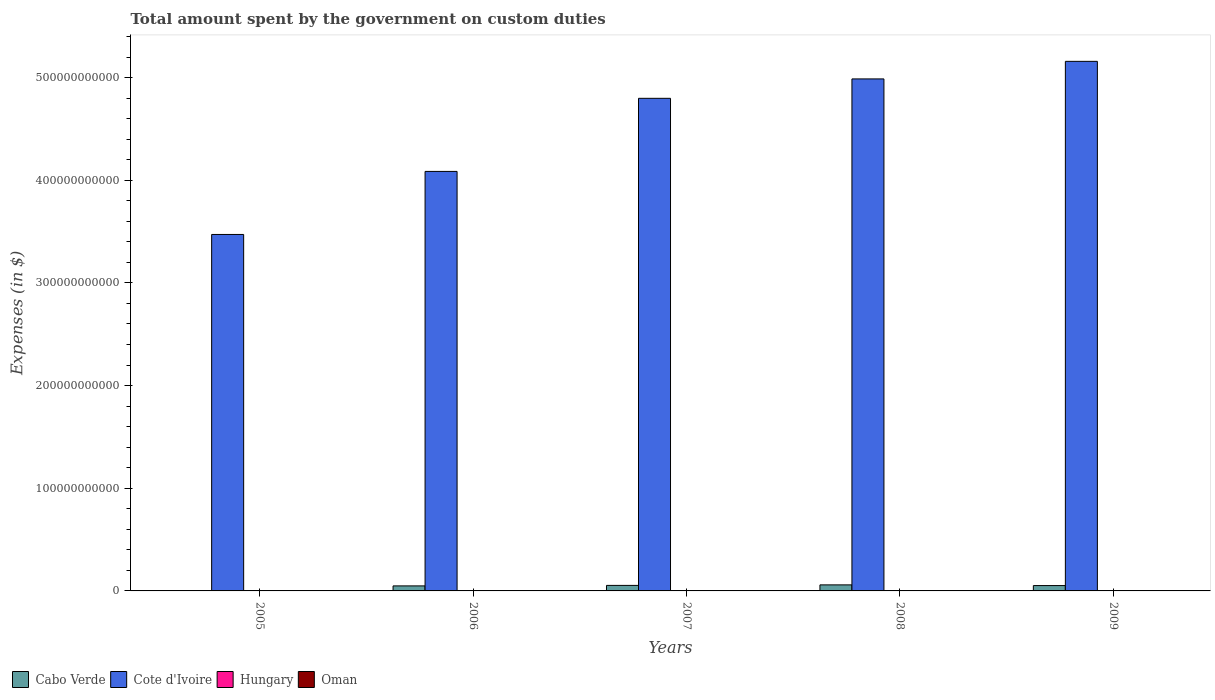Are the number of bars per tick equal to the number of legend labels?
Your answer should be very brief. No. Are the number of bars on each tick of the X-axis equal?
Ensure brevity in your answer.  Yes. What is the label of the 2nd group of bars from the left?
Offer a terse response. 2006. What is the amount spent on custom duties by the government in Oman in 2009?
Offer a very short reply. 1.58e+08. Across all years, what is the maximum amount spent on custom duties by the government in Cote d'Ivoire?
Offer a very short reply. 5.16e+11. Across all years, what is the minimum amount spent on custom duties by the government in Cabo Verde?
Your answer should be very brief. 2.89e+07. What is the total amount spent on custom duties by the government in Cote d'Ivoire in the graph?
Ensure brevity in your answer.  2.25e+12. What is the difference between the amount spent on custom duties by the government in Cabo Verde in 2006 and that in 2007?
Give a very brief answer. -4.88e+08. What is the difference between the amount spent on custom duties by the government in Hungary in 2008 and the amount spent on custom duties by the government in Cabo Verde in 2009?
Ensure brevity in your answer.  -5.22e+09. What is the average amount spent on custom duties by the government in Hungary per year?
Make the answer very short. 0. In the year 2005, what is the difference between the amount spent on custom duties by the government in Oman and amount spent on custom duties by the government in Cote d'Ivoire?
Provide a short and direct response. -3.47e+11. In how many years, is the amount spent on custom duties by the government in Cote d'Ivoire greater than 360000000000 $?
Ensure brevity in your answer.  4. What is the ratio of the amount spent on custom duties by the government in Cote d'Ivoire in 2005 to that in 2007?
Offer a terse response. 0.72. Is the difference between the amount spent on custom duties by the government in Oman in 2006 and 2009 greater than the difference between the amount spent on custom duties by the government in Cote d'Ivoire in 2006 and 2009?
Offer a very short reply. Yes. What is the difference between the highest and the second highest amount spent on custom duties by the government in Oman?
Ensure brevity in your answer.  6.70e+07. What is the difference between the highest and the lowest amount spent on custom duties by the government in Cote d'Ivoire?
Provide a succinct answer. 1.69e+11. In how many years, is the amount spent on custom duties by the government in Cabo Verde greater than the average amount spent on custom duties by the government in Cabo Verde taken over all years?
Keep it short and to the point. 4. Is the sum of the amount spent on custom duties by the government in Cote d'Ivoire in 2005 and 2008 greater than the maximum amount spent on custom duties by the government in Hungary across all years?
Provide a succinct answer. Yes. How many bars are there?
Offer a terse response. 15. How many years are there in the graph?
Your answer should be compact. 5. What is the difference between two consecutive major ticks on the Y-axis?
Give a very brief answer. 1.00e+11. Are the values on the major ticks of Y-axis written in scientific E-notation?
Your response must be concise. No. Does the graph contain grids?
Ensure brevity in your answer.  No. Where does the legend appear in the graph?
Keep it short and to the point. Bottom left. What is the title of the graph?
Make the answer very short. Total amount spent by the government on custom duties. What is the label or title of the X-axis?
Your answer should be compact. Years. What is the label or title of the Y-axis?
Provide a succinct answer. Expenses (in $). What is the Expenses (in $) of Cabo Verde in 2005?
Make the answer very short. 2.89e+07. What is the Expenses (in $) in Cote d'Ivoire in 2005?
Provide a short and direct response. 3.47e+11. What is the Expenses (in $) of Hungary in 2005?
Offer a terse response. 0. What is the Expenses (in $) in Oman in 2005?
Provide a short and direct response. 8.85e+07. What is the Expenses (in $) in Cabo Verde in 2006?
Provide a succinct answer. 4.89e+09. What is the Expenses (in $) of Cote d'Ivoire in 2006?
Your response must be concise. 4.09e+11. What is the Expenses (in $) in Oman in 2006?
Offer a very short reply. 1.15e+08. What is the Expenses (in $) of Cabo Verde in 2007?
Offer a terse response. 5.38e+09. What is the Expenses (in $) in Cote d'Ivoire in 2007?
Ensure brevity in your answer.  4.80e+11. What is the Expenses (in $) of Oman in 2007?
Provide a succinct answer. 1.60e+08. What is the Expenses (in $) of Cabo Verde in 2008?
Your answer should be compact. 5.89e+09. What is the Expenses (in $) of Cote d'Ivoire in 2008?
Your response must be concise. 4.99e+11. What is the Expenses (in $) of Hungary in 2008?
Your answer should be very brief. 0. What is the Expenses (in $) of Oman in 2008?
Your response must be concise. 2.27e+08. What is the Expenses (in $) in Cabo Verde in 2009?
Make the answer very short. 5.22e+09. What is the Expenses (in $) of Cote d'Ivoire in 2009?
Your answer should be very brief. 5.16e+11. What is the Expenses (in $) in Hungary in 2009?
Give a very brief answer. 0. What is the Expenses (in $) in Oman in 2009?
Ensure brevity in your answer.  1.58e+08. Across all years, what is the maximum Expenses (in $) in Cabo Verde?
Provide a short and direct response. 5.89e+09. Across all years, what is the maximum Expenses (in $) in Cote d'Ivoire?
Your response must be concise. 5.16e+11. Across all years, what is the maximum Expenses (in $) of Oman?
Keep it short and to the point. 2.27e+08. Across all years, what is the minimum Expenses (in $) of Cabo Verde?
Provide a succinct answer. 2.89e+07. Across all years, what is the minimum Expenses (in $) in Cote d'Ivoire?
Offer a very short reply. 3.47e+11. Across all years, what is the minimum Expenses (in $) of Oman?
Your answer should be very brief. 8.85e+07. What is the total Expenses (in $) in Cabo Verde in the graph?
Your answer should be very brief. 2.14e+1. What is the total Expenses (in $) of Cote d'Ivoire in the graph?
Make the answer very short. 2.25e+12. What is the total Expenses (in $) of Oman in the graph?
Your answer should be compact. 7.47e+08. What is the difference between the Expenses (in $) of Cabo Verde in 2005 and that in 2006?
Provide a short and direct response. -4.86e+09. What is the difference between the Expenses (in $) in Cote d'Ivoire in 2005 and that in 2006?
Give a very brief answer. -6.14e+1. What is the difference between the Expenses (in $) in Oman in 2005 and that in 2006?
Make the answer very short. -2.61e+07. What is the difference between the Expenses (in $) in Cabo Verde in 2005 and that in 2007?
Provide a succinct answer. -5.35e+09. What is the difference between the Expenses (in $) in Cote d'Ivoire in 2005 and that in 2007?
Provide a short and direct response. -1.33e+11. What is the difference between the Expenses (in $) in Oman in 2005 and that in 2007?
Provide a succinct answer. -7.11e+07. What is the difference between the Expenses (in $) of Cabo Verde in 2005 and that in 2008?
Offer a very short reply. -5.86e+09. What is the difference between the Expenses (in $) of Cote d'Ivoire in 2005 and that in 2008?
Make the answer very short. -1.52e+11. What is the difference between the Expenses (in $) of Oman in 2005 and that in 2008?
Keep it short and to the point. -1.38e+08. What is the difference between the Expenses (in $) in Cabo Verde in 2005 and that in 2009?
Ensure brevity in your answer.  -5.19e+09. What is the difference between the Expenses (in $) in Cote d'Ivoire in 2005 and that in 2009?
Make the answer very short. -1.69e+11. What is the difference between the Expenses (in $) of Oman in 2005 and that in 2009?
Provide a succinct answer. -6.96e+07. What is the difference between the Expenses (in $) in Cabo Verde in 2006 and that in 2007?
Ensure brevity in your answer.  -4.88e+08. What is the difference between the Expenses (in $) of Cote d'Ivoire in 2006 and that in 2007?
Your answer should be compact. -7.12e+1. What is the difference between the Expenses (in $) of Oman in 2006 and that in 2007?
Make the answer very short. -4.50e+07. What is the difference between the Expenses (in $) in Cabo Verde in 2006 and that in 2008?
Your response must be concise. -9.99e+08. What is the difference between the Expenses (in $) in Cote d'Ivoire in 2006 and that in 2008?
Your response must be concise. -9.01e+1. What is the difference between the Expenses (in $) of Oman in 2006 and that in 2008?
Ensure brevity in your answer.  -1.12e+08. What is the difference between the Expenses (in $) of Cabo Verde in 2006 and that in 2009?
Offer a very short reply. -3.30e+08. What is the difference between the Expenses (in $) of Cote d'Ivoire in 2006 and that in 2009?
Provide a short and direct response. -1.07e+11. What is the difference between the Expenses (in $) of Oman in 2006 and that in 2009?
Ensure brevity in your answer.  -4.35e+07. What is the difference between the Expenses (in $) of Cabo Verde in 2007 and that in 2008?
Make the answer very short. -5.12e+08. What is the difference between the Expenses (in $) of Cote d'Ivoire in 2007 and that in 2008?
Offer a very short reply. -1.89e+1. What is the difference between the Expenses (in $) of Oman in 2007 and that in 2008?
Provide a succinct answer. -6.70e+07. What is the difference between the Expenses (in $) in Cabo Verde in 2007 and that in 2009?
Make the answer very short. 1.57e+08. What is the difference between the Expenses (in $) of Cote d'Ivoire in 2007 and that in 2009?
Offer a terse response. -3.60e+1. What is the difference between the Expenses (in $) in Oman in 2007 and that in 2009?
Your response must be concise. 1.50e+06. What is the difference between the Expenses (in $) of Cabo Verde in 2008 and that in 2009?
Make the answer very short. 6.69e+08. What is the difference between the Expenses (in $) in Cote d'Ivoire in 2008 and that in 2009?
Make the answer very short. -1.71e+1. What is the difference between the Expenses (in $) of Oman in 2008 and that in 2009?
Ensure brevity in your answer.  6.85e+07. What is the difference between the Expenses (in $) in Cabo Verde in 2005 and the Expenses (in $) in Cote d'Ivoire in 2006?
Your response must be concise. -4.09e+11. What is the difference between the Expenses (in $) in Cabo Verde in 2005 and the Expenses (in $) in Oman in 2006?
Offer a terse response. -8.57e+07. What is the difference between the Expenses (in $) in Cote d'Ivoire in 2005 and the Expenses (in $) in Oman in 2006?
Offer a terse response. 3.47e+11. What is the difference between the Expenses (in $) of Cabo Verde in 2005 and the Expenses (in $) of Cote d'Ivoire in 2007?
Your answer should be compact. -4.80e+11. What is the difference between the Expenses (in $) in Cabo Verde in 2005 and the Expenses (in $) in Oman in 2007?
Ensure brevity in your answer.  -1.31e+08. What is the difference between the Expenses (in $) in Cote d'Ivoire in 2005 and the Expenses (in $) in Oman in 2007?
Offer a very short reply. 3.47e+11. What is the difference between the Expenses (in $) in Cabo Verde in 2005 and the Expenses (in $) in Cote d'Ivoire in 2008?
Offer a terse response. -4.99e+11. What is the difference between the Expenses (in $) in Cabo Verde in 2005 and the Expenses (in $) in Oman in 2008?
Your answer should be compact. -1.98e+08. What is the difference between the Expenses (in $) of Cote d'Ivoire in 2005 and the Expenses (in $) of Oman in 2008?
Provide a succinct answer. 3.47e+11. What is the difference between the Expenses (in $) of Cabo Verde in 2005 and the Expenses (in $) of Cote d'Ivoire in 2009?
Give a very brief answer. -5.16e+11. What is the difference between the Expenses (in $) of Cabo Verde in 2005 and the Expenses (in $) of Oman in 2009?
Offer a terse response. -1.29e+08. What is the difference between the Expenses (in $) of Cote d'Ivoire in 2005 and the Expenses (in $) of Oman in 2009?
Offer a terse response. 3.47e+11. What is the difference between the Expenses (in $) in Cabo Verde in 2006 and the Expenses (in $) in Cote d'Ivoire in 2007?
Provide a succinct answer. -4.75e+11. What is the difference between the Expenses (in $) of Cabo Verde in 2006 and the Expenses (in $) of Oman in 2007?
Your answer should be compact. 4.73e+09. What is the difference between the Expenses (in $) of Cote d'Ivoire in 2006 and the Expenses (in $) of Oman in 2007?
Provide a succinct answer. 4.08e+11. What is the difference between the Expenses (in $) in Cabo Verde in 2006 and the Expenses (in $) in Cote d'Ivoire in 2008?
Your answer should be very brief. -4.94e+11. What is the difference between the Expenses (in $) in Cabo Verde in 2006 and the Expenses (in $) in Oman in 2008?
Ensure brevity in your answer.  4.66e+09. What is the difference between the Expenses (in $) of Cote d'Ivoire in 2006 and the Expenses (in $) of Oman in 2008?
Make the answer very short. 4.08e+11. What is the difference between the Expenses (in $) of Cabo Verde in 2006 and the Expenses (in $) of Cote d'Ivoire in 2009?
Provide a short and direct response. -5.11e+11. What is the difference between the Expenses (in $) of Cabo Verde in 2006 and the Expenses (in $) of Oman in 2009?
Ensure brevity in your answer.  4.73e+09. What is the difference between the Expenses (in $) of Cote d'Ivoire in 2006 and the Expenses (in $) of Oman in 2009?
Give a very brief answer. 4.08e+11. What is the difference between the Expenses (in $) in Cabo Verde in 2007 and the Expenses (in $) in Cote d'Ivoire in 2008?
Offer a terse response. -4.93e+11. What is the difference between the Expenses (in $) of Cabo Verde in 2007 and the Expenses (in $) of Oman in 2008?
Give a very brief answer. 5.15e+09. What is the difference between the Expenses (in $) of Cote d'Ivoire in 2007 and the Expenses (in $) of Oman in 2008?
Ensure brevity in your answer.  4.80e+11. What is the difference between the Expenses (in $) in Cabo Verde in 2007 and the Expenses (in $) in Cote d'Ivoire in 2009?
Give a very brief answer. -5.10e+11. What is the difference between the Expenses (in $) of Cabo Verde in 2007 and the Expenses (in $) of Oman in 2009?
Make the answer very short. 5.22e+09. What is the difference between the Expenses (in $) of Cote d'Ivoire in 2007 and the Expenses (in $) of Oman in 2009?
Provide a succinct answer. 4.80e+11. What is the difference between the Expenses (in $) in Cabo Verde in 2008 and the Expenses (in $) in Cote d'Ivoire in 2009?
Provide a succinct answer. -5.10e+11. What is the difference between the Expenses (in $) of Cabo Verde in 2008 and the Expenses (in $) of Oman in 2009?
Give a very brief answer. 5.73e+09. What is the difference between the Expenses (in $) of Cote d'Ivoire in 2008 and the Expenses (in $) of Oman in 2009?
Make the answer very short. 4.99e+11. What is the average Expenses (in $) of Cabo Verde per year?
Give a very brief answer. 4.28e+09. What is the average Expenses (in $) of Cote d'Ivoire per year?
Offer a terse response. 4.50e+11. What is the average Expenses (in $) of Oman per year?
Give a very brief answer. 1.49e+08. In the year 2005, what is the difference between the Expenses (in $) in Cabo Verde and Expenses (in $) in Cote d'Ivoire?
Give a very brief answer. -3.47e+11. In the year 2005, what is the difference between the Expenses (in $) in Cabo Verde and Expenses (in $) in Oman?
Your answer should be very brief. -5.96e+07. In the year 2005, what is the difference between the Expenses (in $) of Cote d'Ivoire and Expenses (in $) of Oman?
Your answer should be compact. 3.47e+11. In the year 2006, what is the difference between the Expenses (in $) of Cabo Verde and Expenses (in $) of Cote d'Ivoire?
Keep it short and to the point. -4.04e+11. In the year 2006, what is the difference between the Expenses (in $) of Cabo Verde and Expenses (in $) of Oman?
Provide a succinct answer. 4.77e+09. In the year 2006, what is the difference between the Expenses (in $) of Cote d'Ivoire and Expenses (in $) of Oman?
Your response must be concise. 4.08e+11. In the year 2007, what is the difference between the Expenses (in $) of Cabo Verde and Expenses (in $) of Cote d'Ivoire?
Provide a succinct answer. -4.74e+11. In the year 2007, what is the difference between the Expenses (in $) in Cabo Verde and Expenses (in $) in Oman?
Provide a succinct answer. 5.22e+09. In the year 2007, what is the difference between the Expenses (in $) in Cote d'Ivoire and Expenses (in $) in Oman?
Provide a succinct answer. 4.80e+11. In the year 2008, what is the difference between the Expenses (in $) in Cabo Verde and Expenses (in $) in Cote d'Ivoire?
Keep it short and to the point. -4.93e+11. In the year 2008, what is the difference between the Expenses (in $) in Cabo Verde and Expenses (in $) in Oman?
Offer a very short reply. 5.66e+09. In the year 2008, what is the difference between the Expenses (in $) in Cote d'Ivoire and Expenses (in $) in Oman?
Keep it short and to the point. 4.98e+11. In the year 2009, what is the difference between the Expenses (in $) in Cabo Verde and Expenses (in $) in Cote d'Ivoire?
Provide a succinct answer. -5.11e+11. In the year 2009, what is the difference between the Expenses (in $) of Cabo Verde and Expenses (in $) of Oman?
Provide a succinct answer. 5.06e+09. In the year 2009, what is the difference between the Expenses (in $) of Cote d'Ivoire and Expenses (in $) of Oman?
Your answer should be compact. 5.16e+11. What is the ratio of the Expenses (in $) in Cabo Verde in 2005 to that in 2006?
Keep it short and to the point. 0.01. What is the ratio of the Expenses (in $) of Cote d'Ivoire in 2005 to that in 2006?
Offer a terse response. 0.85. What is the ratio of the Expenses (in $) in Oman in 2005 to that in 2006?
Your answer should be very brief. 0.77. What is the ratio of the Expenses (in $) in Cabo Verde in 2005 to that in 2007?
Your answer should be very brief. 0.01. What is the ratio of the Expenses (in $) of Cote d'Ivoire in 2005 to that in 2007?
Make the answer very short. 0.72. What is the ratio of the Expenses (in $) of Oman in 2005 to that in 2007?
Provide a succinct answer. 0.55. What is the ratio of the Expenses (in $) in Cabo Verde in 2005 to that in 2008?
Ensure brevity in your answer.  0. What is the ratio of the Expenses (in $) of Cote d'Ivoire in 2005 to that in 2008?
Provide a short and direct response. 0.7. What is the ratio of the Expenses (in $) of Oman in 2005 to that in 2008?
Your answer should be very brief. 0.39. What is the ratio of the Expenses (in $) in Cabo Verde in 2005 to that in 2009?
Make the answer very short. 0.01. What is the ratio of the Expenses (in $) in Cote d'Ivoire in 2005 to that in 2009?
Give a very brief answer. 0.67. What is the ratio of the Expenses (in $) of Oman in 2005 to that in 2009?
Make the answer very short. 0.56. What is the ratio of the Expenses (in $) in Cabo Verde in 2006 to that in 2007?
Offer a terse response. 0.91. What is the ratio of the Expenses (in $) in Cote d'Ivoire in 2006 to that in 2007?
Your answer should be very brief. 0.85. What is the ratio of the Expenses (in $) of Oman in 2006 to that in 2007?
Your answer should be very brief. 0.72. What is the ratio of the Expenses (in $) in Cabo Verde in 2006 to that in 2008?
Make the answer very short. 0.83. What is the ratio of the Expenses (in $) in Cote d'Ivoire in 2006 to that in 2008?
Offer a terse response. 0.82. What is the ratio of the Expenses (in $) of Oman in 2006 to that in 2008?
Keep it short and to the point. 0.51. What is the ratio of the Expenses (in $) in Cabo Verde in 2006 to that in 2009?
Offer a terse response. 0.94. What is the ratio of the Expenses (in $) of Cote d'Ivoire in 2006 to that in 2009?
Keep it short and to the point. 0.79. What is the ratio of the Expenses (in $) in Oman in 2006 to that in 2009?
Offer a terse response. 0.72. What is the ratio of the Expenses (in $) of Cabo Verde in 2007 to that in 2008?
Give a very brief answer. 0.91. What is the ratio of the Expenses (in $) in Cote d'Ivoire in 2007 to that in 2008?
Make the answer very short. 0.96. What is the ratio of the Expenses (in $) of Oman in 2007 to that in 2008?
Your response must be concise. 0.7. What is the ratio of the Expenses (in $) of Cabo Verde in 2007 to that in 2009?
Offer a very short reply. 1.03. What is the ratio of the Expenses (in $) in Cote d'Ivoire in 2007 to that in 2009?
Provide a succinct answer. 0.93. What is the ratio of the Expenses (in $) in Oman in 2007 to that in 2009?
Ensure brevity in your answer.  1.01. What is the ratio of the Expenses (in $) in Cabo Verde in 2008 to that in 2009?
Your answer should be very brief. 1.13. What is the ratio of the Expenses (in $) in Cote d'Ivoire in 2008 to that in 2009?
Ensure brevity in your answer.  0.97. What is the ratio of the Expenses (in $) of Oman in 2008 to that in 2009?
Provide a short and direct response. 1.43. What is the difference between the highest and the second highest Expenses (in $) in Cabo Verde?
Ensure brevity in your answer.  5.12e+08. What is the difference between the highest and the second highest Expenses (in $) in Cote d'Ivoire?
Provide a short and direct response. 1.71e+1. What is the difference between the highest and the second highest Expenses (in $) of Oman?
Your answer should be very brief. 6.70e+07. What is the difference between the highest and the lowest Expenses (in $) in Cabo Verde?
Keep it short and to the point. 5.86e+09. What is the difference between the highest and the lowest Expenses (in $) of Cote d'Ivoire?
Your response must be concise. 1.69e+11. What is the difference between the highest and the lowest Expenses (in $) in Oman?
Your response must be concise. 1.38e+08. 